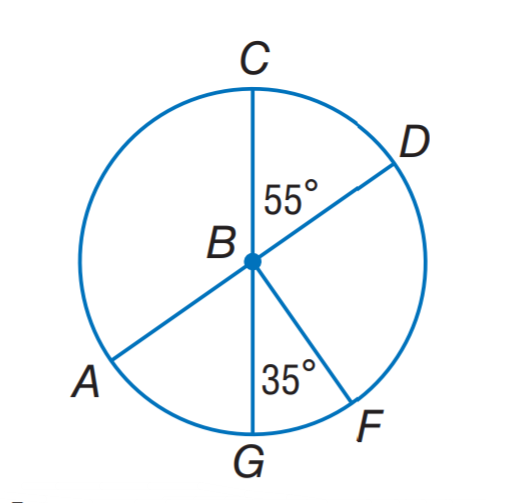Answer the mathemtical geometry problem and directly provide the correct option letter.
Question: A D and C G are diameters of \odot B. Find m \widehat C G D.
Choices: A: 55 B: 275 C: 295 D: 305 D 